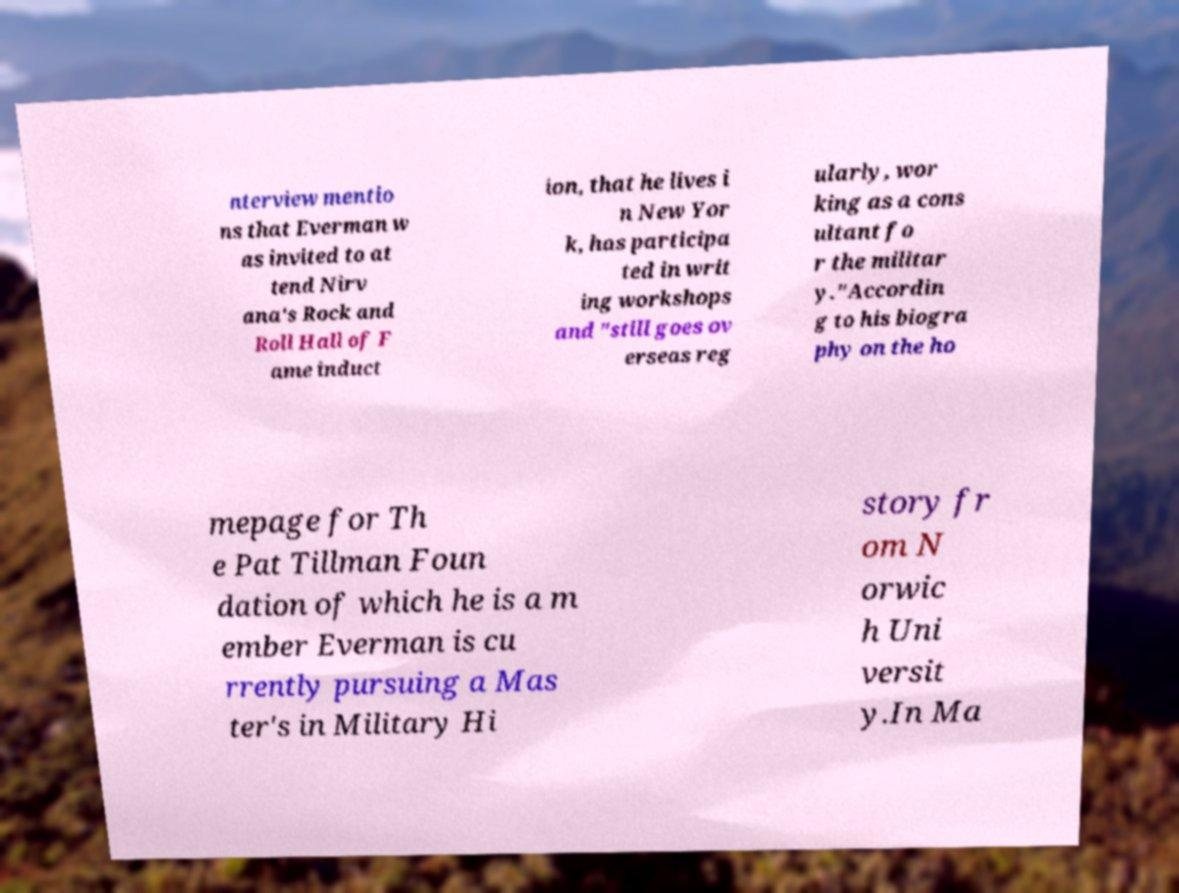What messages or text are displayed in this image? I need them in a readable, typed format. nterview mentio ns that Everman w as invited to at tend Nirv ana's Rock and Roll Hall of F ame induct ion, that he lives i n New Yor k, has participa ted in writ ing workshops and "still goes ov erseas reg ularly, wor king as a cons ultant fo r the militar y."Accordin g to his biogra phy on the ho mepage for Th e Pat Tillman Foun dation of which he is a m ember Everman is cu rrently pursuing a Mas ter's in Military Hi story fr om N orwic h Uni versit y.In Ma 